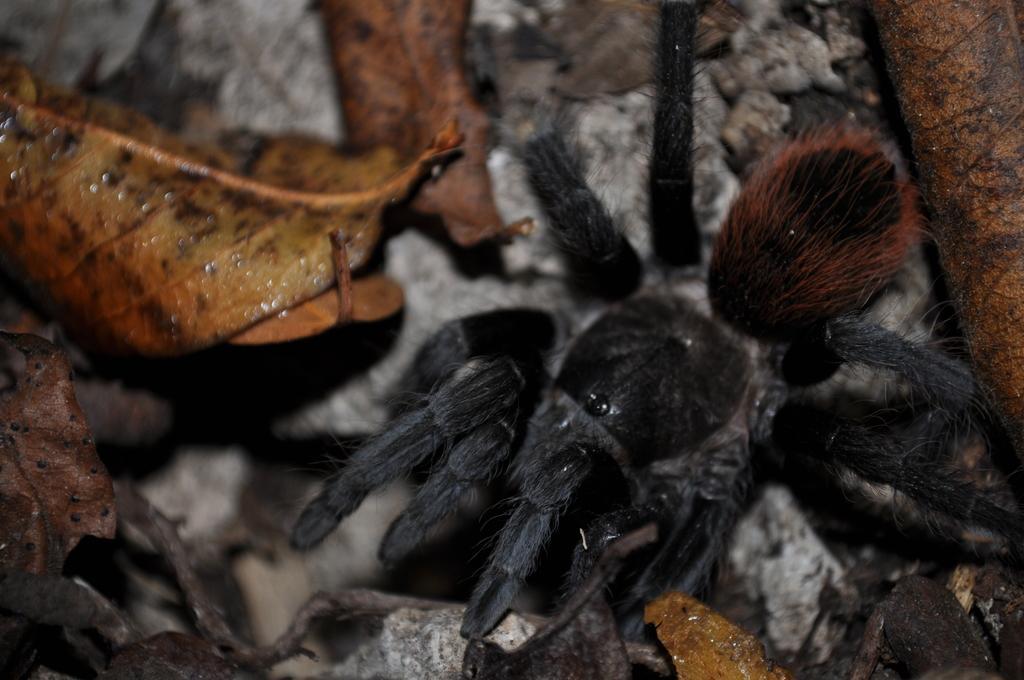In one or two sentences, can you explain what this image depicts? In this image we can see black color spider on the ground. Here we can see dry leaves and stones. 